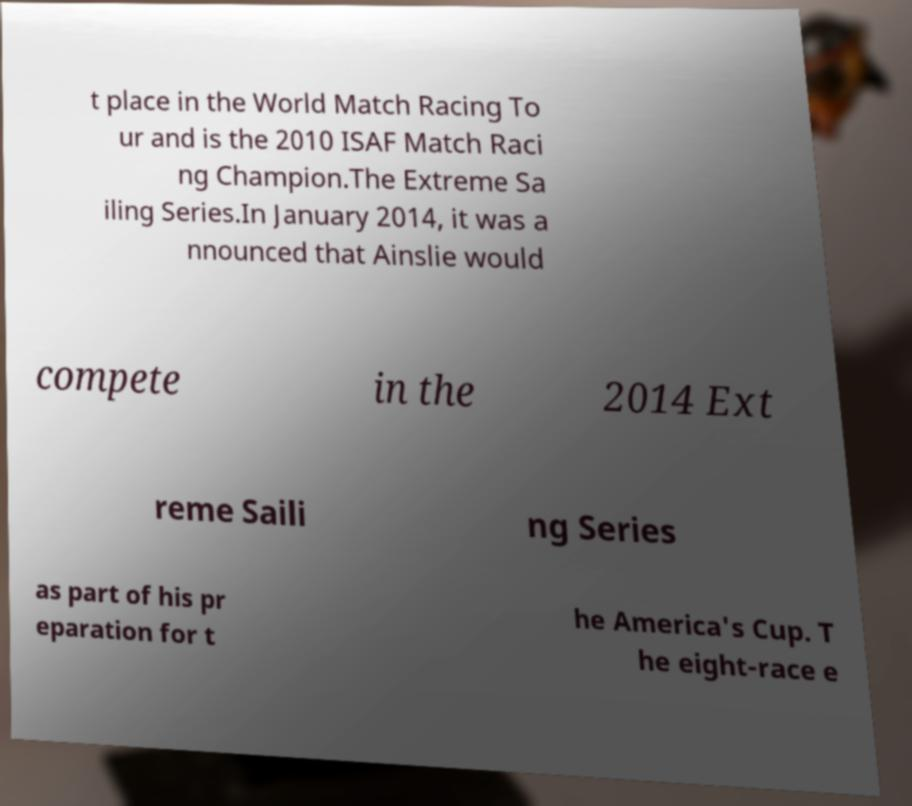Could you extract and type out the text from this image? t place in the World Match Racing To ur and is the 2010 ISAF Match Raci ng Champion.The Extreme Sa iling Series.In January 2014, it was a nnounced that Ainslie would compete in the 2014 Ext reme Saili ng Series as part of his pr eparation for t he America's Cup. T he eight-race e 